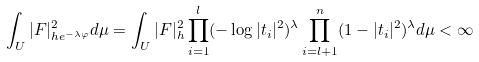<formula> <loc_0><loc_0><loc_500><loc_500>\int _ { U } | F | _ { h e ^ { - \lambda \varphi } } ^ { 2 } d \mu = \int _ { U } | F | _ { h } ^ { 2 } \prod _ { i = 1 } ^ { l } ( - \log | t _ { i } | ^ { 2 } ) ^ { \lambda } \prod _ { i = l + 1 } ^ { n } ( 1 - | t _ { i } | ^ { 2 } ) ^ { \lambda } d \mu < \infty</formula> 